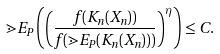<formula> <loc_0><loc_0><loc_500><loc_500>\mathbb { m } { E } _ { P } \left ( \left ( \frac { f ( K _ { n } ( X _ { n } ) ) } { f ( \mathbb { m } { E } _ { P } ( K _ { n } ( X _ { n } ) ) ) } \right ) ^ { \eta } \right ) \leq C .</formula> 